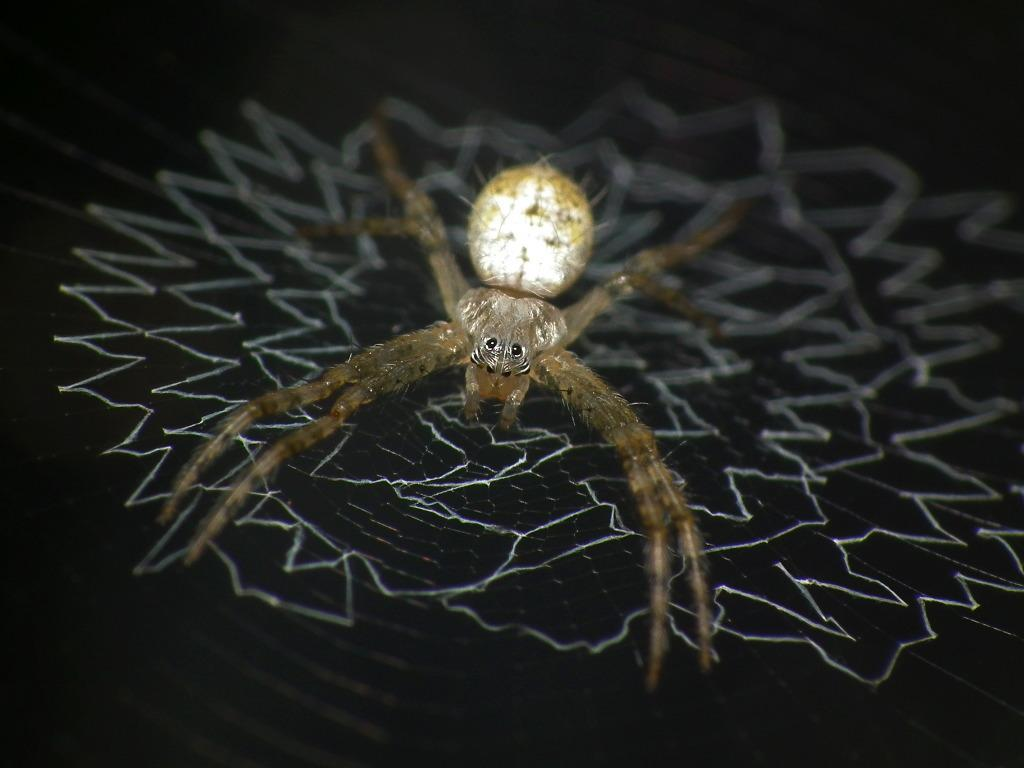What is the main subject of the image? There is a spider in the image. What is associated with the spider in the image? There is a spider web in the image. What can be observed about the overall appearance of the image? The background of the image is dark in color. What type of toothpaste is being used to clean the spider web in the image? There is no toothpaste present in the image, and the spider web is not being cleaned. What kind of fold can be seen in the spider's legs in the image? There are no folds in the spider's legs visible in the image. 